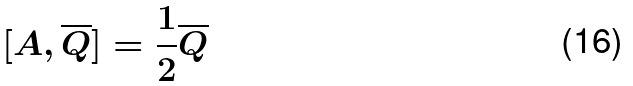Convert formula to latex. <formula><loc_0><loc_0><loc_500><loc_500>[ A , \overline { Q } ] = \frac { 1 } { 2 } \overline { Q }</formula> 